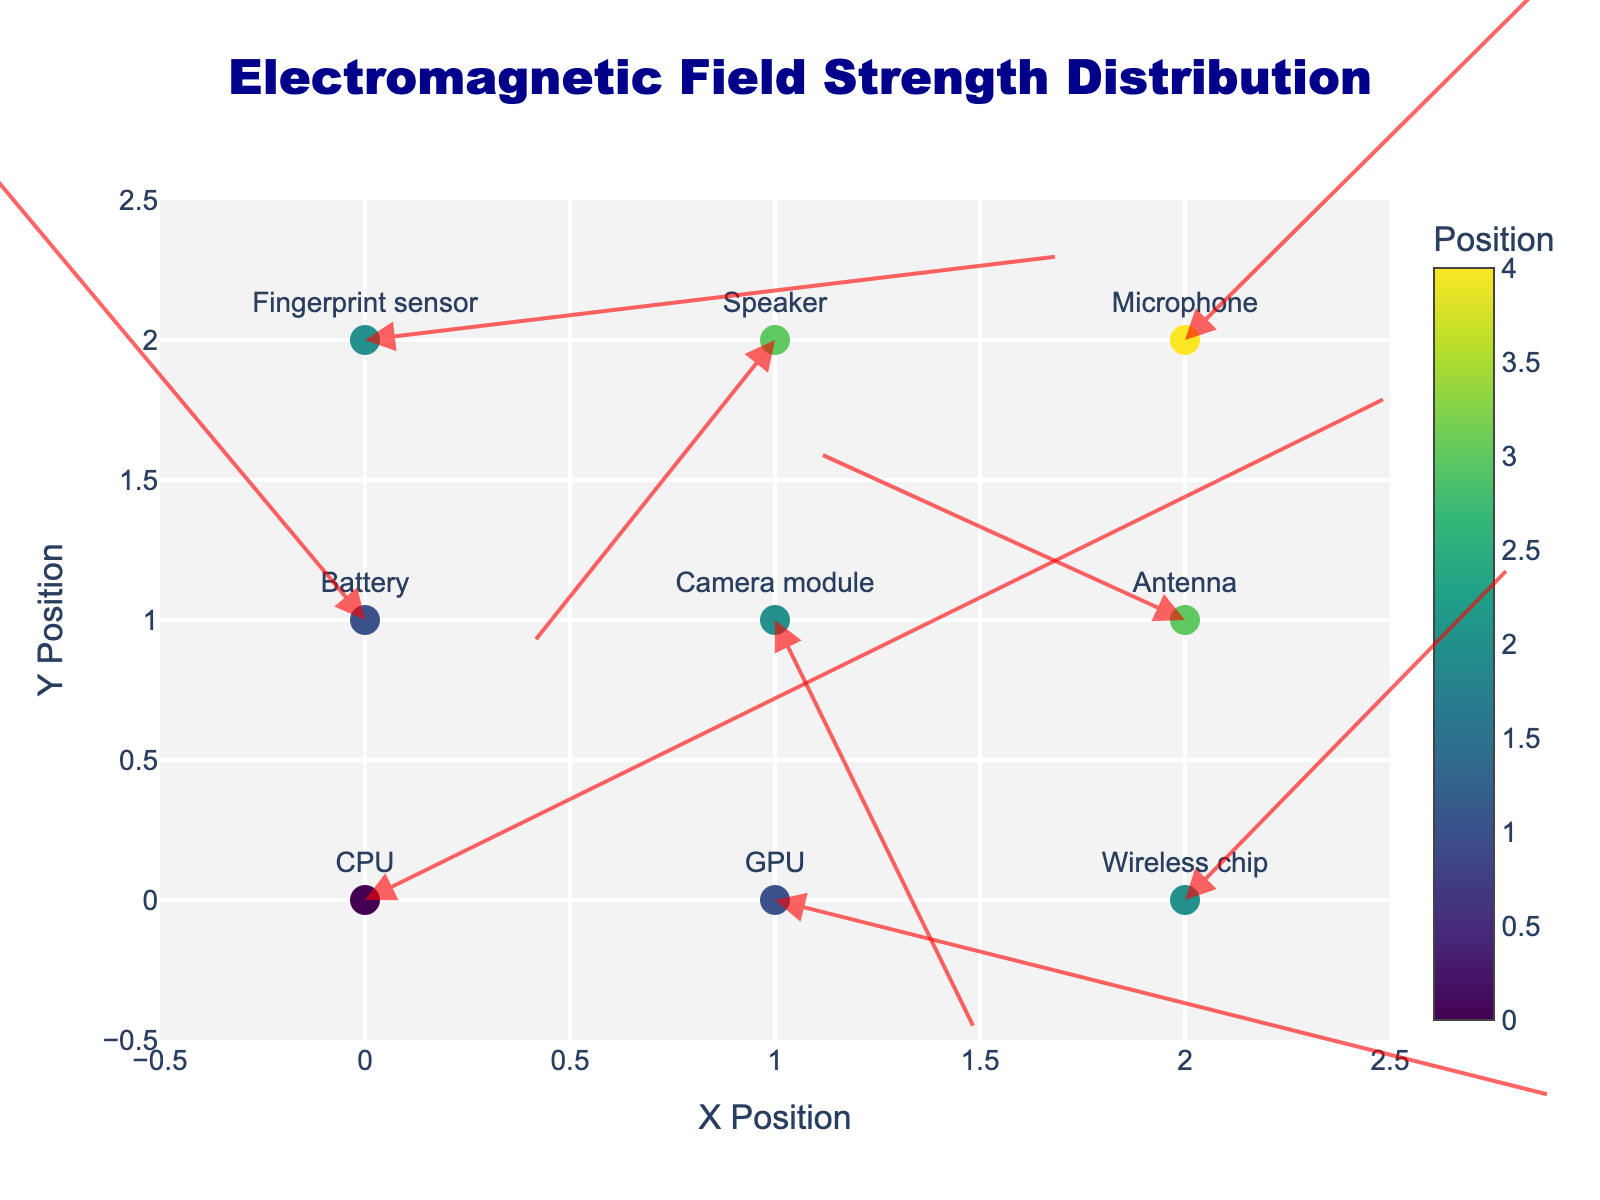What's the title of the plot? The title is prominently displayed at the top of the figure.
Answer: Electromagnetic Field Strength Distribution What are the labels of the x and y axes? The axis labels are specified at the bottom of the x-axis and the left side of the y-axis.
Answer: X Position, Y Position How many different smartphone components are shown in the plot? By counting the unique component labels in the plot, we determine the number of components.
Answer: 9 Which smartphone component has the largest upward electromagnetic field strength? The component with the largest positive value of the y-component (v) of the vector representation indicates the largest upward strength. This is found by scanning the values.
Answer: Battery Are there any components with a negative electromagnetic field strength in the x-direction? If so, which ones? Components with a negative value of the x-component (u) of the vector represent negative electromagnetic field strength in the x-direction. These are identified by checking the 'u' values in the data.
Answer: Battery, Camera module, Speaker What is the sum of vector components in the x-direction (u) for the CPU, Wireless chip, and Microphone? The sum is calculated by adding the x-components (u) values for CPU, Wireless chip, and Microphone. Specifically, 2.5 + 0.8 + 1.1.
Answer: 4.4 Which component is positioned at the coordinate (1, 1)? By matching the coordinates (1, 1) with the corresponding component in the data, we find the component.
Answer: Camera module Which component has a horizontal electromagnetic field strength vector of 2.5? The horizontal strength is represented by the x-component (u) value. By checking which component has u = 2.5, we identify the component.
Answer: CPU Between the GPU and the Camera module, which has a greater negative strength in the y-direction? Comparing the y-components (v) of the GPU and Camera module, we look for the component with the more negative value. -0.7 (GPU) vs. -1.5 (Camera module).
Answer: Camera module What is the color associated with the Battery on the plot? Colors are determined by the 'position' values in which the positions are encoded as colors based on a 'Viridis' color scale. We find the range that matches the color representation of the y-component.
Answer: A shade of green-to-yellow 